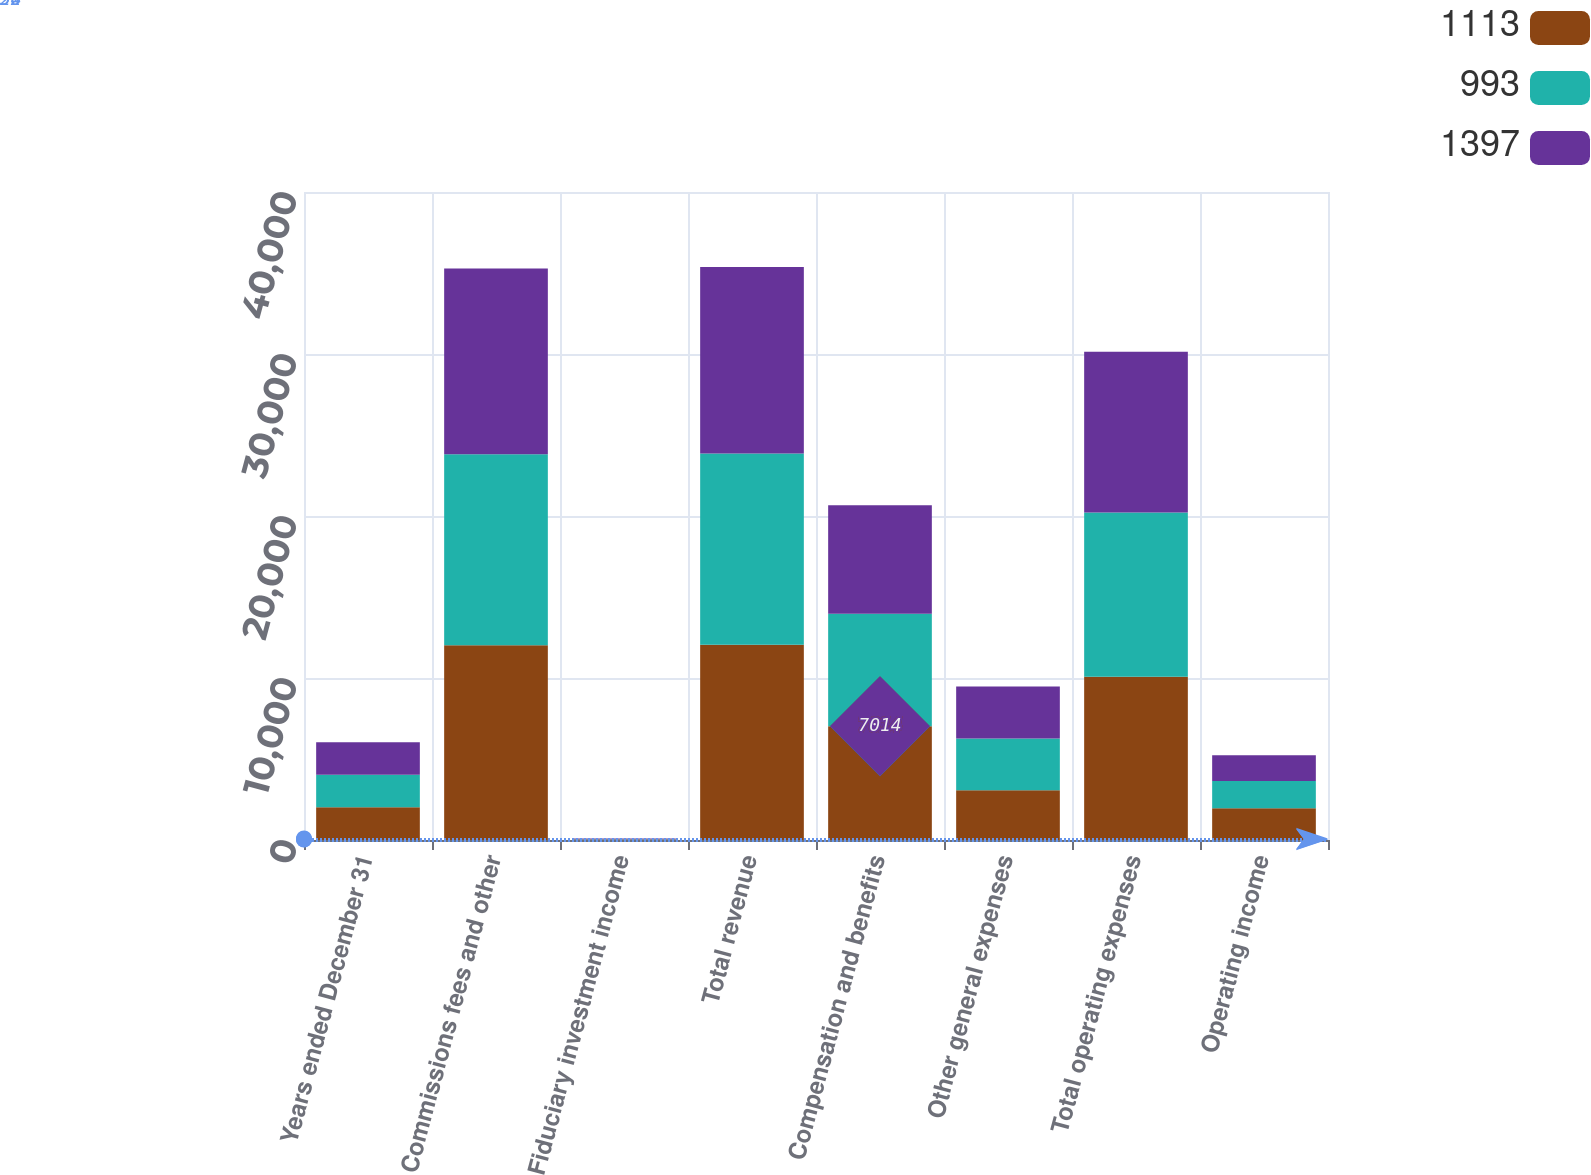Convert chart. <chart><loc_0><loc_0><loc_500><loc_500><stacked_bar_chart><ecel><fcel>Years ended December 31<fcel>Commissions fees and other<fcel>Fiduciary investment income<fcel>Total revenue<fcel>Compensation and benefits<fcel>Other general expenses<fcel>Total operating expenses<fcel>Operating income<nl><fcel>1113<fcel>2014<fcel>12019<fcel>26<fcel>12045<fcel>7014<fcel>3065<fcel>10079<fcel>1966<nl><fcel>993<fcel>2013<fcel>11787<fcel>28<fcel>11815<fcel>6945<fcel>3199<fcel>10144<fcel>1671<nl><fcel>1397<fcel>2012<fcel>11476<fcel>38<fcel>11514<fcel>6709<fcel>3209<fcel>9918<fcel>1596<nl></chart> 